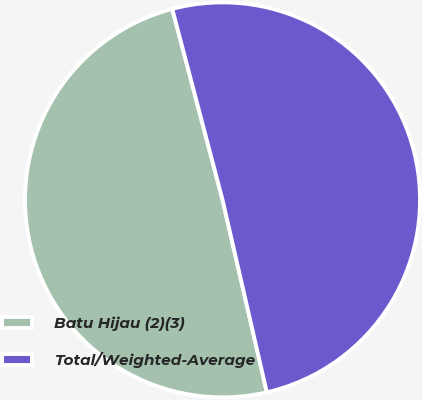<chart> <loc_0><loc_0><loc_500><loc_500><pie_chart><fcel>Batu Hijau (2)(3)<fcel>Total/Weighted-Average<nl><fcel>49.5%<fcel>50.5%<nl></chart> 